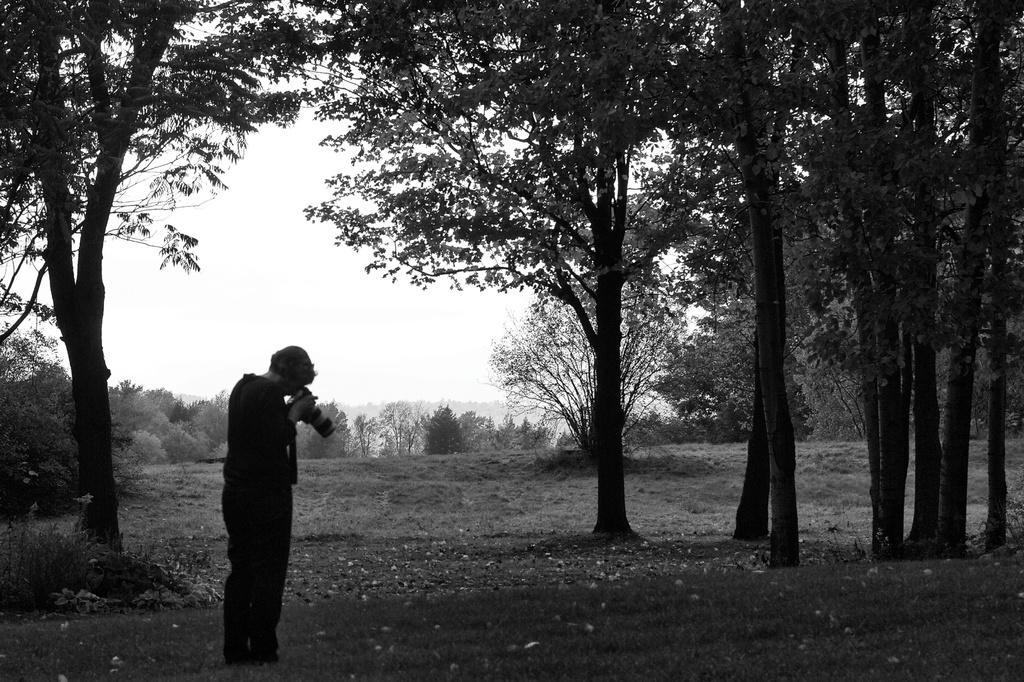Can you describe this image briefly? In this picture I can see a person standing and holding a camera, there are trees, and in the background there is the sky. 